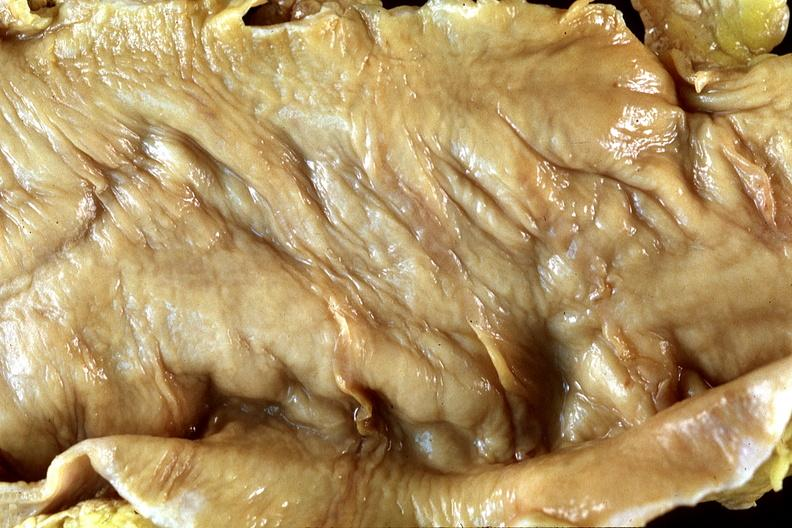does normal ovary show normal colon?
Answer the question using a single word or phrase. No 